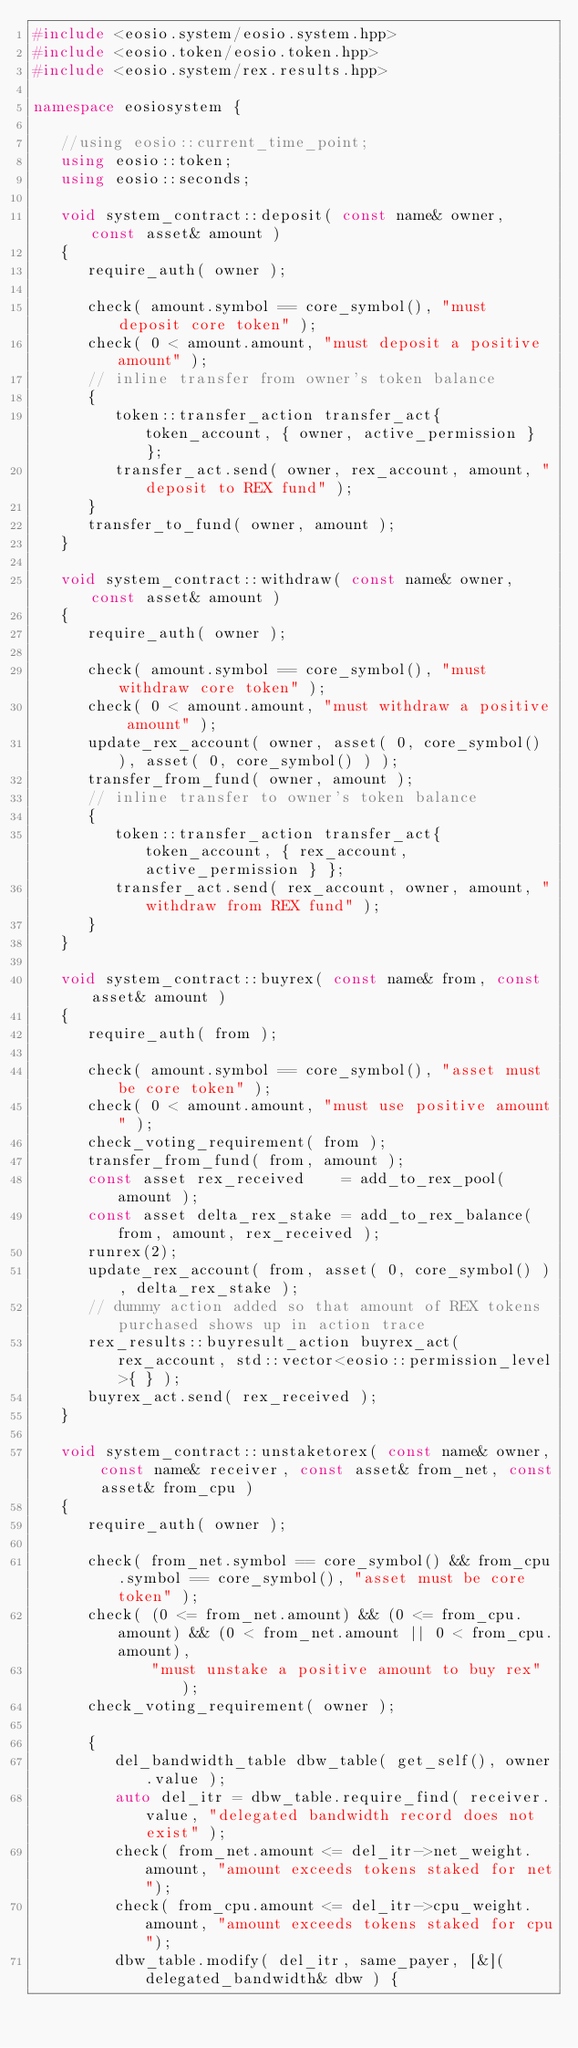Convert code to text. <code><loc_0><loc_0><loc_500><loc_500><_C++_>#include <eosio.system/eosio.system.hpp>
#include <eosio.token/eosio.token.hpp>
#include <eosio.system/rex.results.hpp>

namespace eosiosystem {

   //using eosio::current_time_point;
   using eosio::token;
   using eosio::seconds;

   void system_contract::deposit( const name& owner, const asset& amount )
   {
      require_auth( owner );

      check( amount.symbol == core_symbol(), "must deposit core token" );
      check( 0 < amount.amount, "must deposit a positive amount" );
      // inline transfer from owner's token balance
      {
         token::transfer_action transfer_act{ token_account, { owner, active_permission } };
         transfer_act.send( owner, rex_account, amount, "deposit to REX fund" );
      }
      transfer_to_fund( owner, amount );
   }

   void system_contract::withdraw( const name& owner, const asset& amount )
   {
      require_auth( owner );

      check( amount.symbol == core_symbol(), "must withdraw core token" );
      check( 0 < amount.amount, "must withdraw a positive amount" );
      update_rex_account( owner, asset( 0, core_symbol() ), asset( 0, core_symbol() ) );
      transfer_from_fund( owner, amount );
      // inline transfer to owner's token balance
      {
         token::transfer_action transfer_act{ token_account, { rex_account, active_permission } };
         transfer_act.send( rex_account, owner, amount, "withdraw from REX fund" );
      }
   }

   void system_contract::buyrex( const name& from, const asset& amount )
   {
      require_auth( from );

      check( amount.symbol == core_symbol(), "asset must be core token" );
      check( 0 < amount.amount, "must use positive amount" );
      check_voting_requirement( from );
      transfer_from_fund( from, amount );
      const asset rex_received    = add_to_rex_pool( amount );
      const asset delta_rex_stake = add_to_rex_balance( from, amount, rex_received );
      runrex(2);
      update_rex_account( from, asset( 0, core_symbol() ), delta_rex_stake );
      // dummy action added so that amount of REX tokens purchased shows up in action trace
      rex_results::buyresult_action buyrex_act( rex_account, std::vector<eosio::permission_level>{ } );
      buyrex_act.send( rex_received );
   }

   void system_contract::unstaketorex( const name& owner, const name& receiver, const asset& from_net, const asset& from_cpu )
   {
      require_auth( owner );

      check( from_net.symbol == core_symbol() && from_cpu.symbol == core_symbol(), "asset must be core token" );
      check( (0 <= from_net.amount) && (0 <= from_cpu.amount) && (0 < from_net.amount || 0 < from_cpu.amount),
             "must unstake a positive amount to buy rex" );
      check_voting_requirement( owner );

      {
         del_bandwidth_table dbw_table( get_self(), owner.value );
         auto del_itr = dbw_table.require_find( receiver.value, "delegated bandwidth record does not exist" );
         check( from_net.amount <= del_itr->net_weight.amount, "amount exceeds tokens staked for net");
         check( from_cpu.amount <= del_itr->cpu_weight.amount, "amount exceeds tokens staked for cpu");
         dbw_table.modify( del_itr, same_payer, [&]( delegated_bandwidth& dbw ) {</code> 